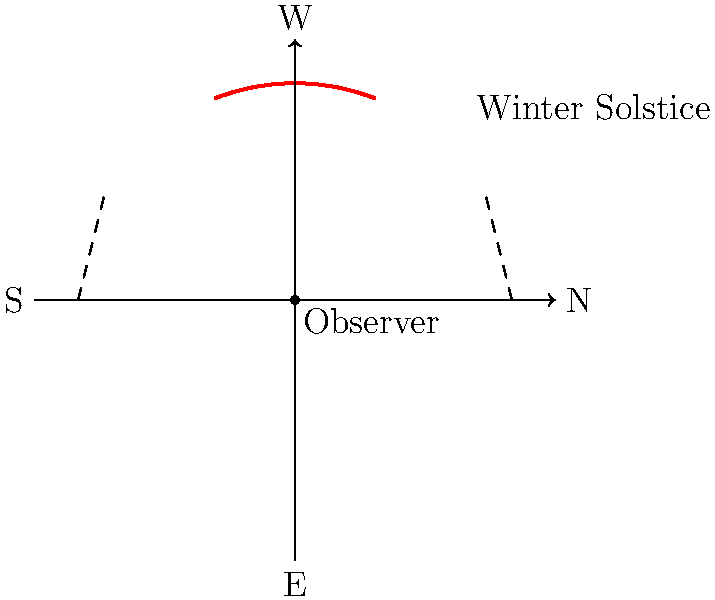As a Canadian family observing the sky throughout the year, you've noticed changes in the Sun's path. During the winter solstice, at approximately what latitude in Canada would the Sun's path across the sky look like the one shown in the diagram? To determine the latitude, we need to analyze the Sun's path in the diagram:

1. The diagram shows the Sun's path during the winter solstice, when the Sun is at its lowest point in the sky for the Northern Hemisphere.

2. The Sun's declination at the winter solstice is approximately $-23.5°$.

3. The maximum altitude of the Sun occurs at solar noon, which is the highest point of the arc in the diagram.

4. We can use the formula: $h_{max} = 90° - \text{latitude} + \text{declination}$

   Where $h_{max}$ is the maximum altitude of the Sun.

5. From the diagram, we can estimate that $h_{max}$ is about $21.5°$.

6. Substituting the values into the formula:
   $21.5° = 90° - \text{latitude} + (-23.5°)$

7. Solving for latitude:
   $\text{latitude} = 90° - 21.5° - 23.5° = 45°$

Therefore, the latitude that corresponds to this Sun path during the winter solstice is approximately 45° North.
Answer: 45° North 